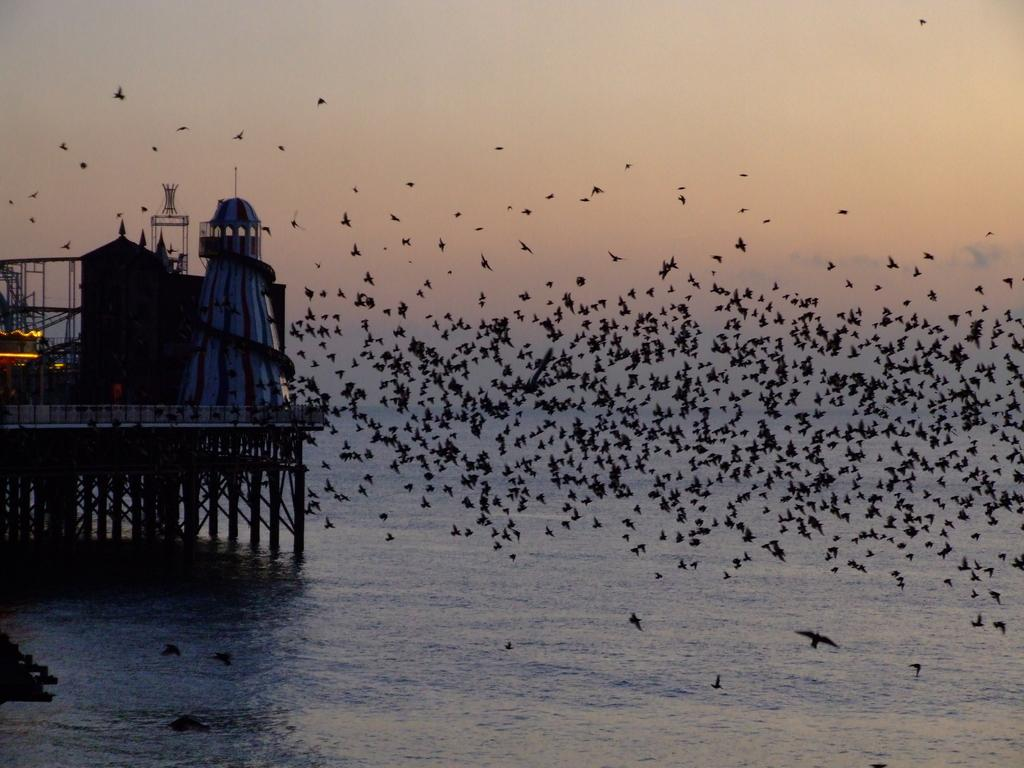What type of structures can be seen in the image? There are buildings in the image. What objects are present in the image that resemble long, thin bars? There are rods in the image. What type of animals are visible in the image? There are birds in the image. What natural element can be seen in the image? There is water visible in the image. What is visible in the background of the image? The sky is visible in the background of the image. What type of wood can be seen cracking in the image? There is no wood or cracking visible in the image. What type of system is being used to control the birds in the image? There is no system controlling the birds in the image; they are free-flying. 